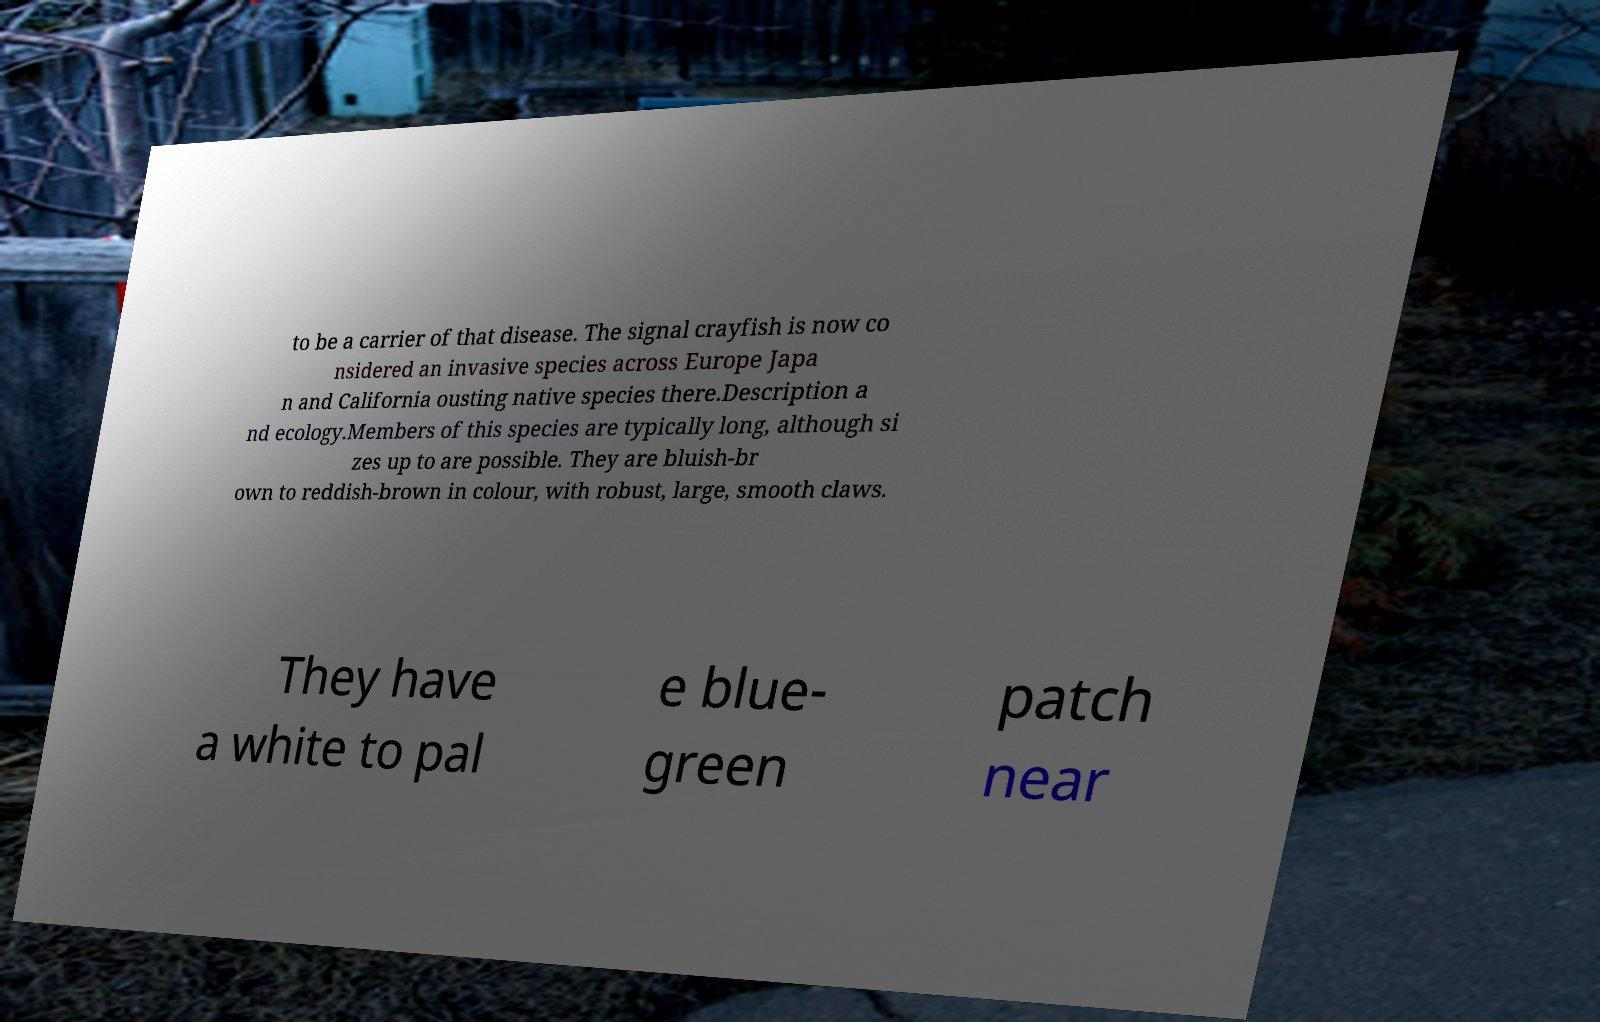Could you assist in decoding the text presented in this image and type it out clearly? to be a carrier of that disease. The signal crayfish is now co nsidered an invasive species across Europe Japa n and California ousting native species there.Description a nd ecology.Members of this species are typically long, although si zes up to are possible. They are bluish-br own to reddish-brown in colour, with robust, large, smooth claws. They have a white to pal e blue- green patch near 